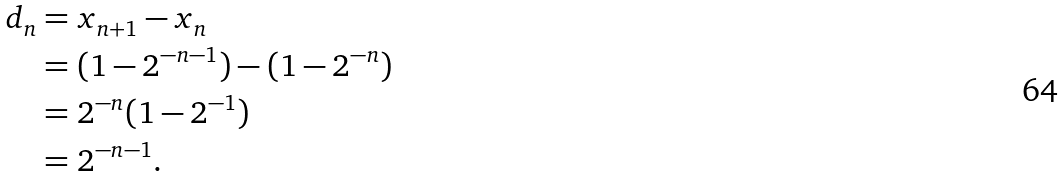Convert formula to latex. <formula><loc_0><loc_0><loc_500><loc_500>d _ { n } & = x _ { n + 1 } - x _ { n } \\ & = ( 1 - 2 ^ { - n - 1 } ) - ( 1 - 2 ^ { - n } ) \\ & = 2 ^ { - n } ( 1 - 2 ^ { - 1 } ) \\ & = 2 ^ { - n - 1 } .</formula> 